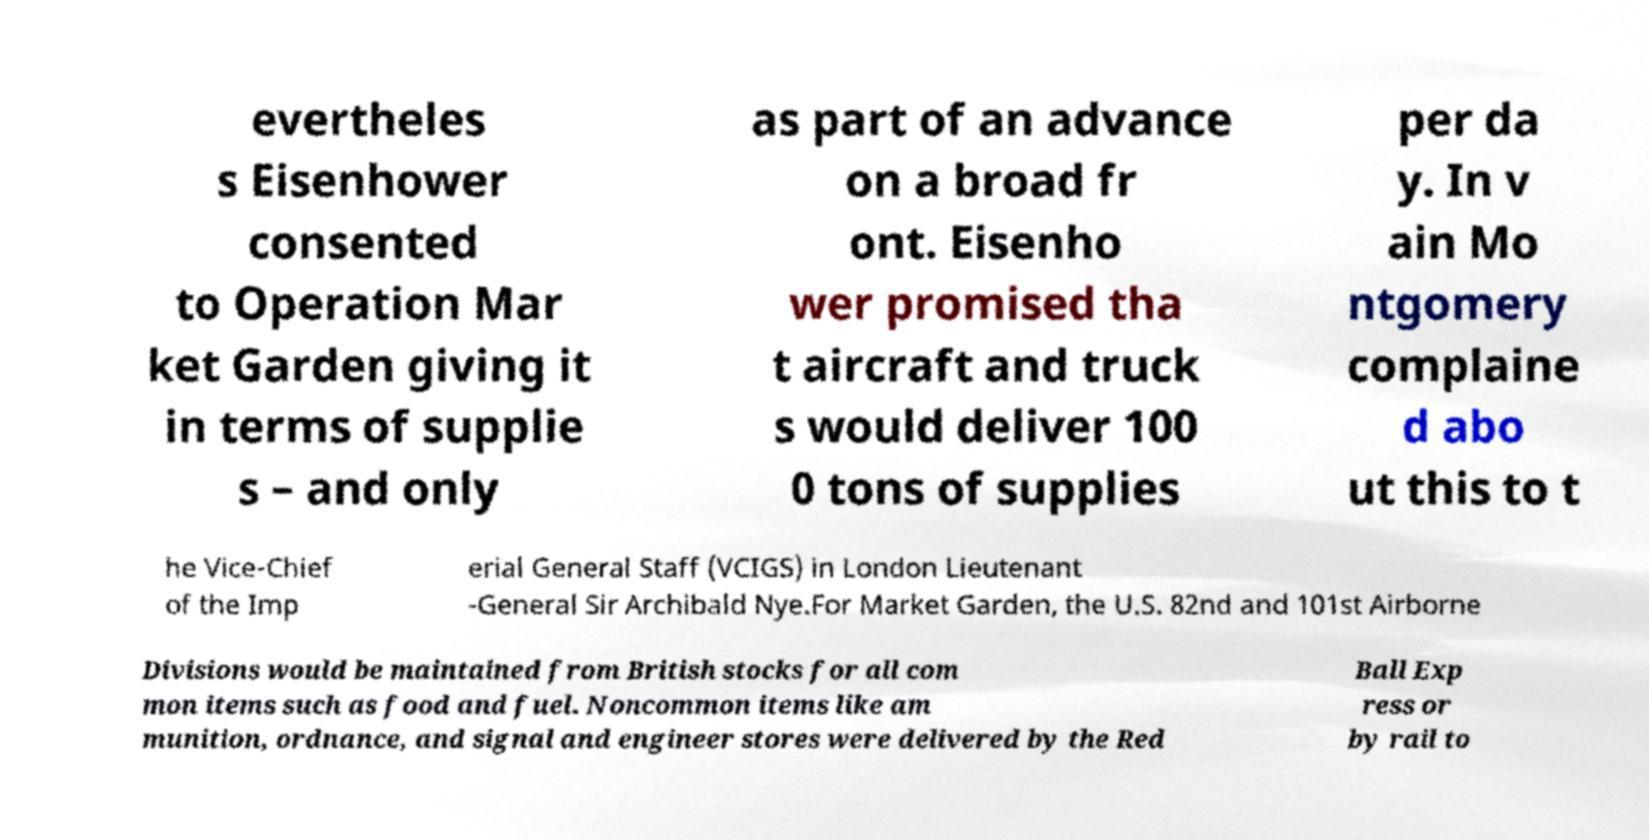Please identify and transcribe the text found in this image. evertheles s Eisenhower consented to Operation Mar ket Garden giving it in terms of supplie s – and only as part of an advance on a broad fr ont. Eisenho wer promised tha t aircraft and truck s would deliver 100 0 tons of supplies per da y. In v ain Mo ntgomery complaine d abo ut this to t he Vice-Chief of the Imp erial General Staff (VCIGS) in London Lieutenant -General Sir Archibald Nye.For Market Garden, the U.S. 82nd and 101st Airborne Divisions would be maintained from British stocks for all com mon items such as food and fuel. Noncommon items like am munition, ordnance, and signal and engineer stores were delivered by the Red Ball Exp ress or by rail to 